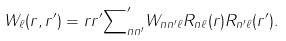<formula> <loc_0><loc_0><loc_500><loc_500>W _ { \ell } ( r , r ^ { \prime } ) = r r ^ { \prime } { \sum } ^ { \prime } _ { n n ^ { \prime } } W _ { n n ^ { \prime } \ell } R _ { n \ell } ( r ) R _ { n ^ { \prime } \ell } ( r ^ { \prime } ) .</formula> 